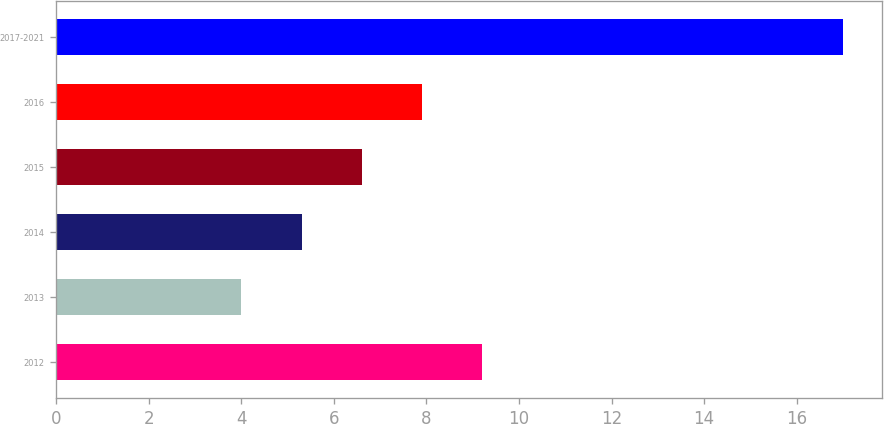Convert chart. <chart><loc_0><loc_0><loc_500><loc_500><bar_chart><fcel>2012<fcel>2013<fcel>2014<fcel>2015<fcel>2016<fcel>2017-2021<nl><fcel>9.2<fcel>4<fcel>5.3<fcel>6.6<fcel>7.9<fcel>17<nl></chart> 